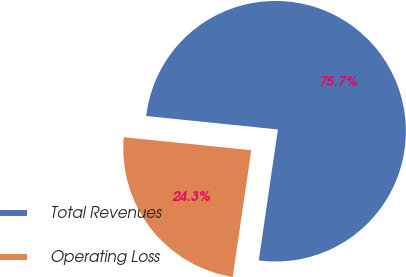<chart> <loc_0><loc_0><loc_500><loc_500><pie_chart><fcel>Total Revenues<fcel>Operating Loss<nl><fcel>75.69%<fcel>24.31%<nl></chart> 